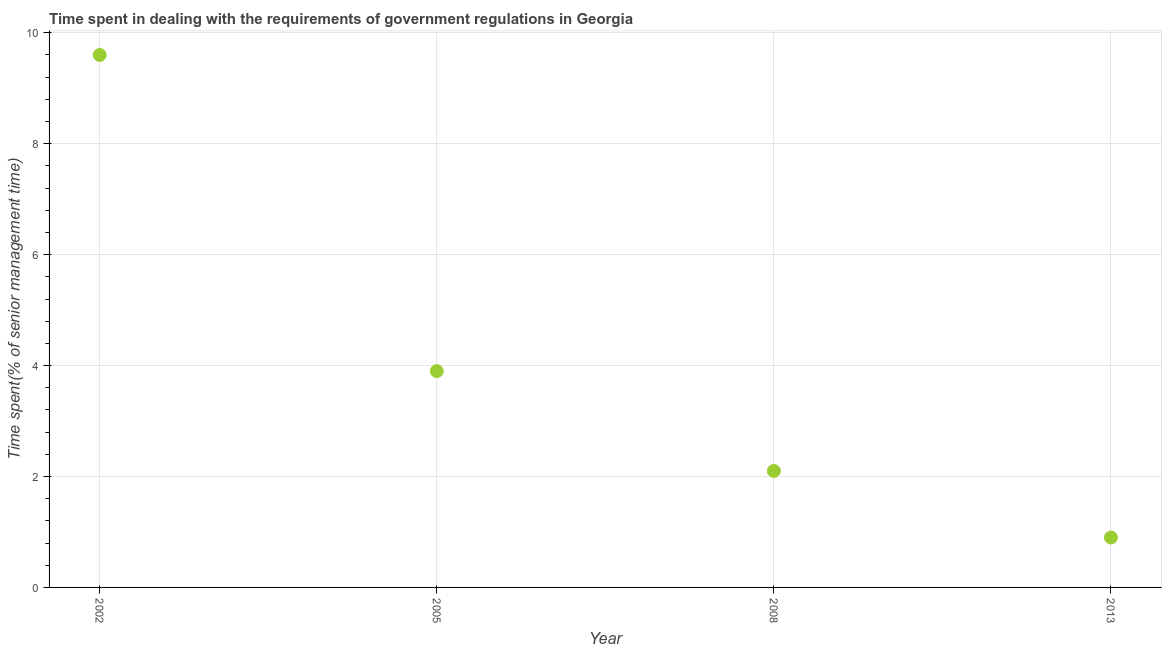What is the time spent in dealing with government regulations in 2008?
Ensure brevity in your answer.  2.1. Across all years, what is the maximum time spent in dealing with government regulations?
Your response must be concise. 9.6. Across all years, what is the minimum time spent in dealing with government regulations?
Provide a short and direct response. 0.9. In which year was the time spent in dealing with government regulations maximum?
Keep it short and to the point. 2002. What is the sum of the time spent in dealing with government regulations?
Your response must be concise. 16.5. What is the difference between the time spent in dealing with government regulations in 2005 and 2008?
Provide a short and direct response. 1.8. What is the average time spent in dealing with government regulations per year?
Your answer should be compact. 4.12. What is the median time spent in dealing with government regulations?
Ensure brevity in your answer.  3. In how many years, is the time spent in dealing with government regulations greater than 3.2 %?
Make the answer very short. 2. What is the ratio of the time spent in dealing with government regulations in 2002 to that in 2013?
Your answer should be very brief. 10.67. Is the time spent in dealing with government regulations in 2002 less than that in 2008?
Make the answer very short. No. What is the difference between the highest and the second highest time spent in dealing with government regulations?
Your answer should be compact. 5.7. Is the sum of the time spent in dealing with government regulations in 2008 and 2013 greater than the maximum time spent in dealing with government regulations across all years?
Offer a terse response. No. What is the difference between the highest and the lowest time spent in dealing with government regulations?
Offer a very short reply. 8.7. How many dotlines are there?
Give a very brief answer. 1. What is the difference between two consecutive major ticks on the Y-axis?
Your response must be concise. 2. Does the graph contain any zero values?
Your answer should be compact. No. What is the title of the graph?
Offer a terse response. Time spent in dealing with the requirements of government regulations in Georgia. What is the label or title of the X-axis?
Your answer should be compact. Year. What is the label or title of the Y-axis?
Provide a succinct answer. Time spent(% of senior management time). What is the Time spent(% of senior management time) in 2002?
Give a very brief answer. 9.6. What is the Time spent(% of senior management time) in 2005?
Your answer should be very brief. 3.9. What is the Time spent(% of senior management time) in 2008?
Provide a short and direct response. 2.1. What is the difference between the Time spent(% of senior management time) in 2002 and 2008?
Offer a very short reply. 7.5. What is the difference between the Time spent(% of senior management time) in 2002 and 2013?
Make the answer very short. 8.7. What is the difference between the Time spent(% of senior management time) in 2005 and 2008?
Keep it short and to the point. 1.8. What is the difference between the Time spent(% of senior management time) in 2005 and 2013?
Provide a short and direct response. 3. What is the difference between the Time spent(% of senior management time) in 2008 and 2013?
Provide a short and direct response. 1.2. What is the ratio of the Time spent(% of senior management time) in 2002 to that in 2005?
Keep it short and to the point. 2.46. What is the ratio of the Time spent(% of senior management time) in 2002 to that in 2008?
Ensure brevity in your answer.  4.57. What is the ratio of the Time spent(% of senior management time) in 2002 to that in 2013?
Offer a terse response. 10.67. What is the ratio of the Time spent(% of senior management time) in 2005 to that in 2008?
Keep it short and to the point. 1.86. What is the ratio of the Time spent(% of senior management time) in 2005 to that in 2013?
Keep it short and to the point. 4.33. What is the ratio of the Time spent(% of senior management time) in 2008 to that in 2013?
Your answer should be very brief. 2.33. 